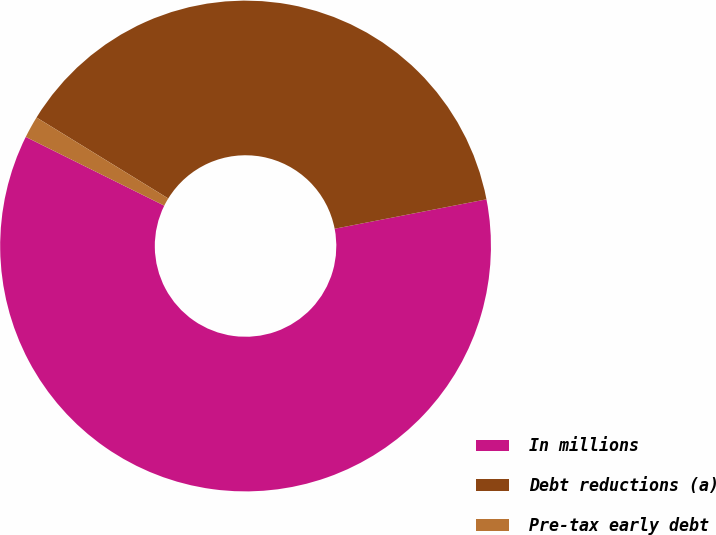Convert chart. <chart><loc_0><loc_0><loc_500><loc_500><pie_chart><fcel>In millions<fcel>Debt reductions (a)<fcel>Pre-tax early debt<nl><fcel>60.38%<fcel>38.18%<fcel>1.44%<nl></chart> 